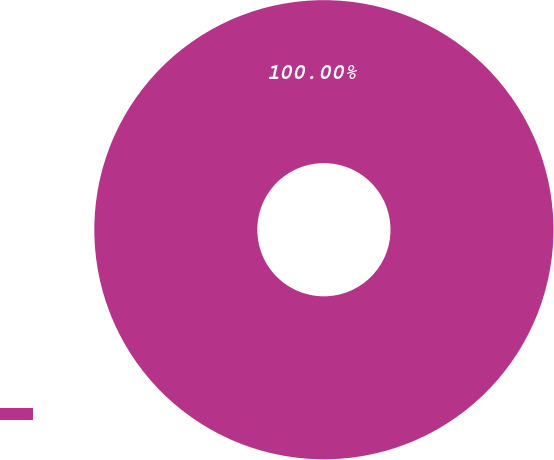<chart> <loc_0><loc_0><loc_500><loc_500><pie_chart><ecel><nl><fcel>100.0%<nl></chart> 